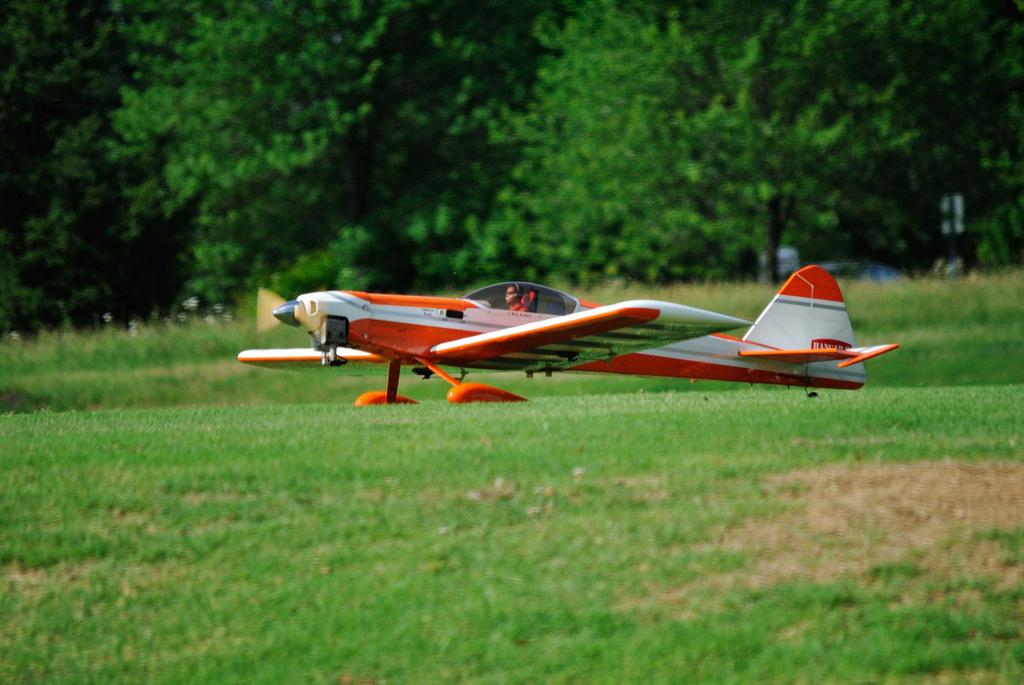What is the main subject in the center of the image? There is an aeroplane in the center of the image. Can you describe the person inside the aeroplane? There is a person sitting in the aeroplane. What type of vegetation is visible at the bottom of the image? There is grass at the bottom of the image. What can be seen in the background of the image? There are trees in the background of the image. How many boxes can be seen stacked on top of each other in the image? There are no boxes present in the image. 